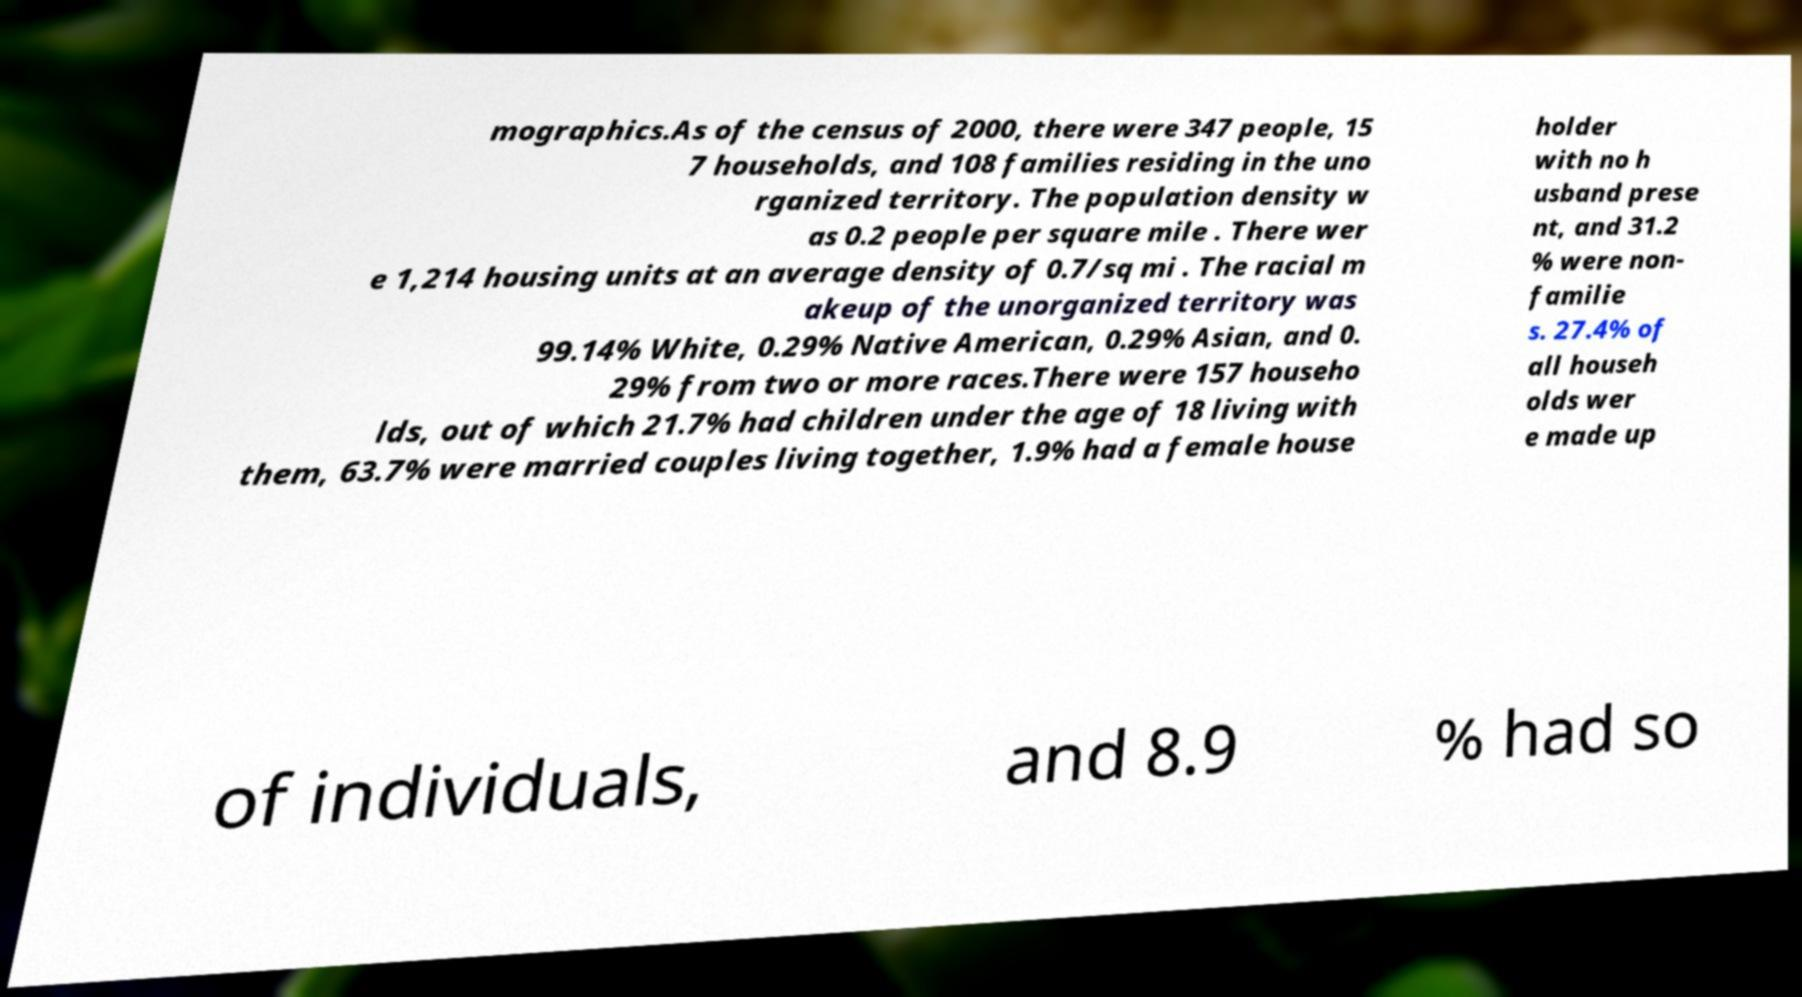I need the written content from this picture converted into text. Can you do that? mographics.As of the census of 2000, there were 347 people, 15 7 households, and 108 families residing in the uno rganized territory. The population density w as 0.2 people per square mile . There wer e 1,214 housing units at an average density of 0.7/sq mi . The racial m akeup of the unorganized territory was 99.14% White, 0.29% Native American, 0.29% Asian, and 0. 29% from two or more races.There were 157 househo lds, out of which 21.7% had children under the age of 18 living with them, 63.7% were married couples living together, 1.9% had a female house holder with no h usband prese nt, and 31.2 % were non- familie s. 27.4% of all househ olds wer e made up of individuals, and 8.9 % had so 